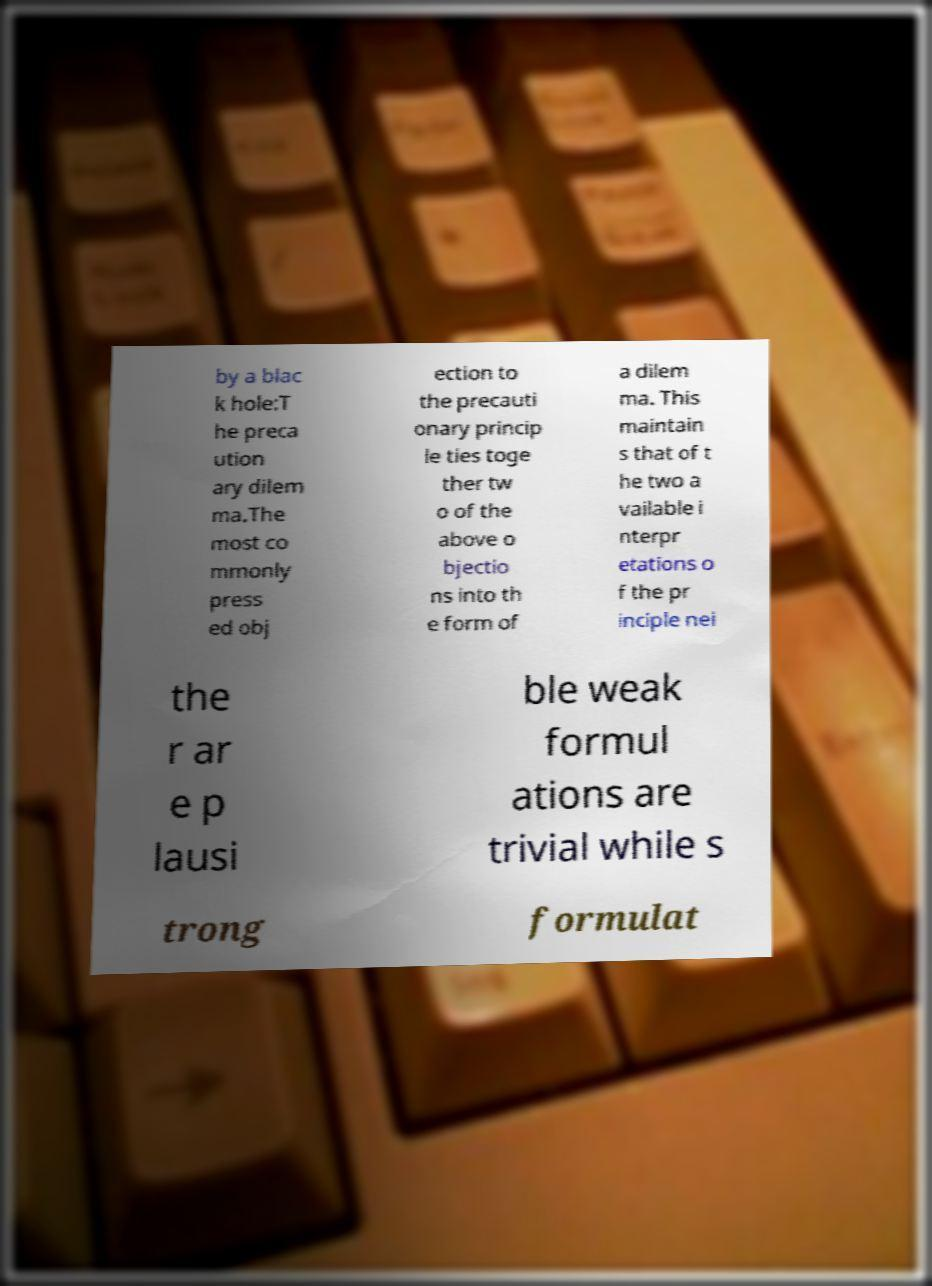Please identify and transcribe the text found in this image. by a blac k hole:T he preca ution ary dilem ma.The most co mmonly press ed obj ection to the precauti onary princip le ties toge ther tw o of the above o bjectio ns into th e form of a dilem ma. This maintain s that of t he two a vailable i nterpr etations o f the pr inciple nei the r ar e p lausi ble weak formul ations are trivial while s trong formulat 